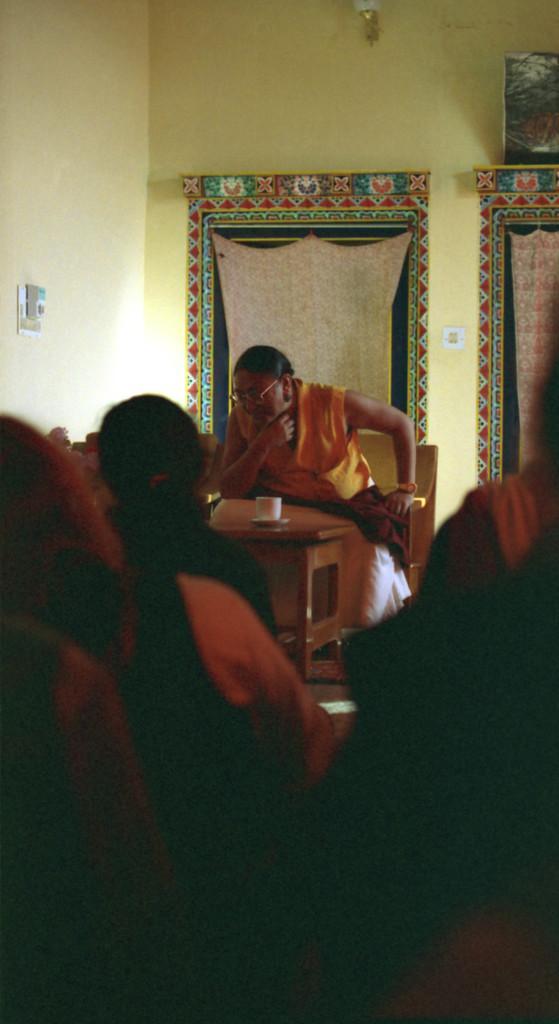In one or two sentences, can you explain what this image depicts? In the foreground we can see people. in the middle there are chair, table, cup and person. In the background there are curtains, frame, wall and light. On the left we can see switches and a regulator on the wall. 